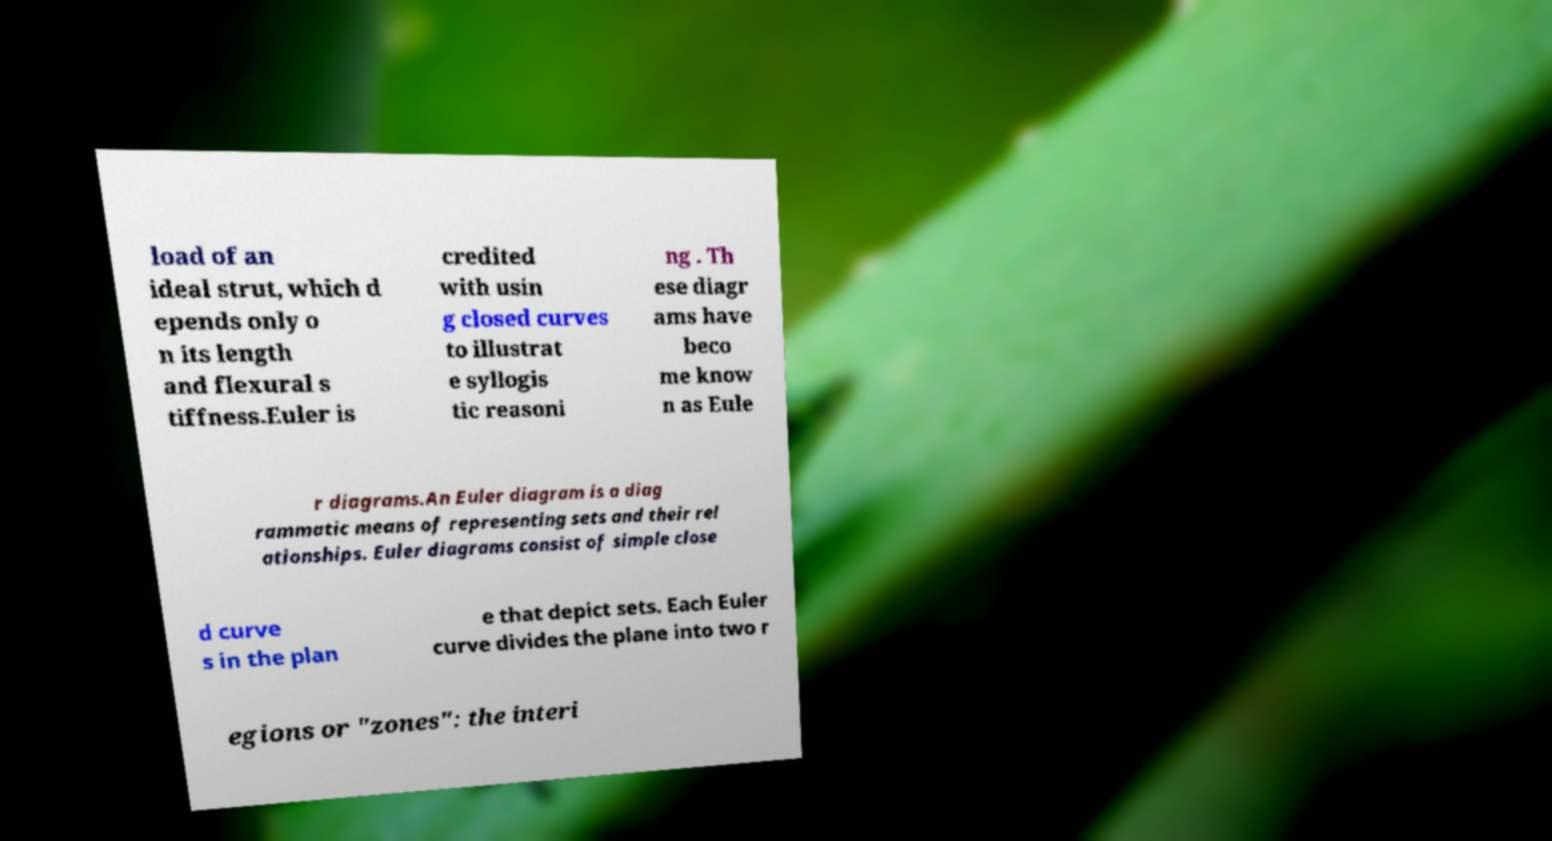Could you assist in decoding the text presented in this image and type it out clearly? load of an ideal strut, which d epends only o n its length and flexural s tiffness.Euler is credited with usin g closed curves to illustrat e syllogis tic reasoni ng . Th ese diagr ams have beco me know n as Eule r diagrams.An Euler diagram is a diag rammatic means of representing sets and their rel ationships. Euler diagrams consist of simple close d curve s in the plan e that depict sets. Each Euler curve divides the plane into two r egions or "zones": the interi 